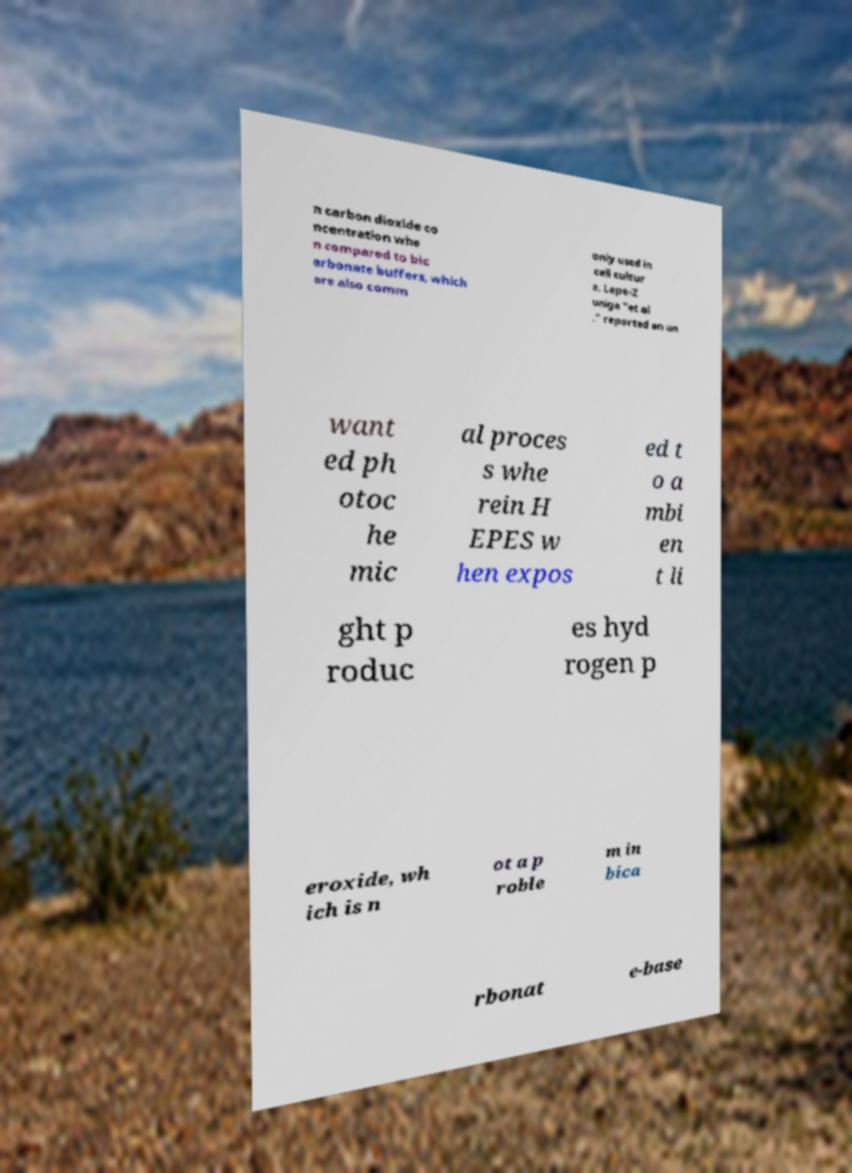What messages or text are displayed in this image? I need them in a readable, typed format. n carbon dioxide co ncentration whe n compared to bic arbonate buffers, which are also comm only used in cell cultur e. Lepe-Z uniga "et al ." reported an un want ed ph otoc he mic al proces s whe rein H EPES w hen expos ed t o a mbi en t li ght p roduc es hyd rogen p eroxide, wh ich is n ot a p roble m in bica rbonat e-base 